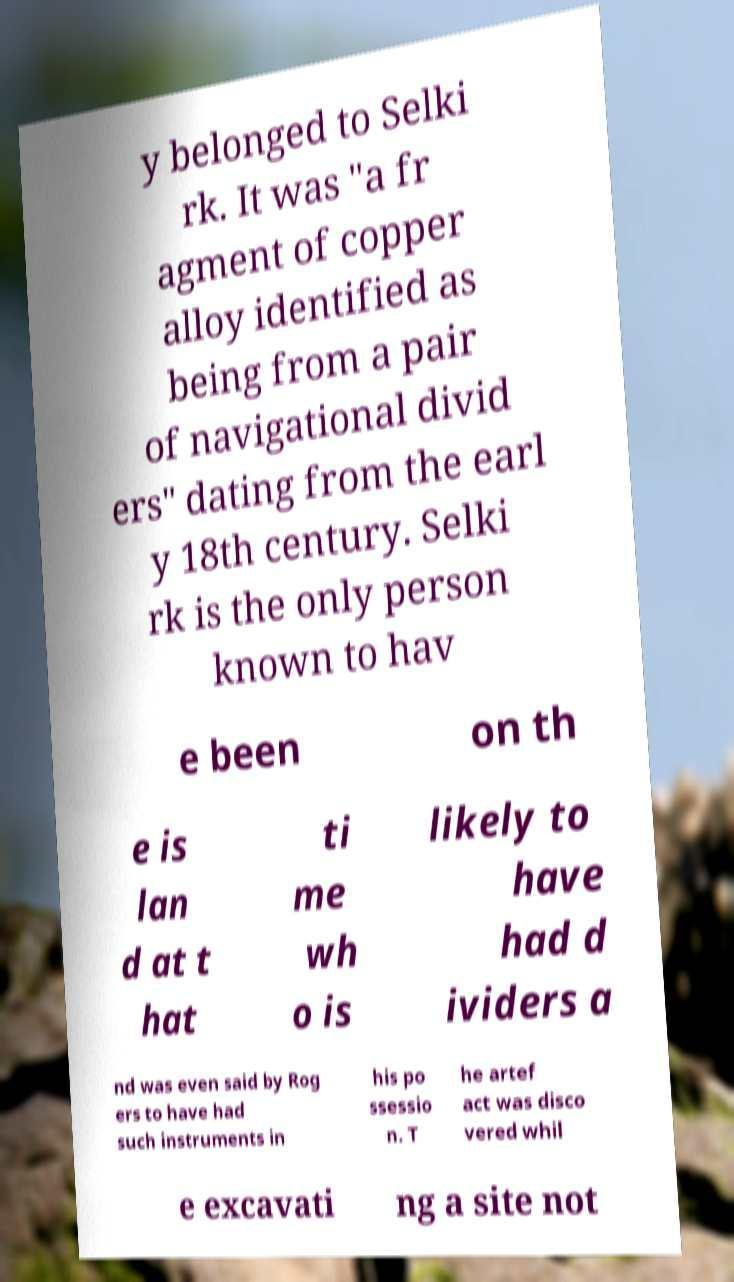Please identify and transcribe the text found in this image. y belonged to Selki rk. It was "a fr agment of copper alloy identified as being from a pair of navigational divid ers" dating from the earl y 18th century. Selki rk is the only person known to hav e been on th e is lan d at t hat ti me wh o is likely to have had d ividers a nd was even said by Rog ers to have had such instruments in his po ssessio n. T he artef act was disco vered whil e excavati ng a site not 